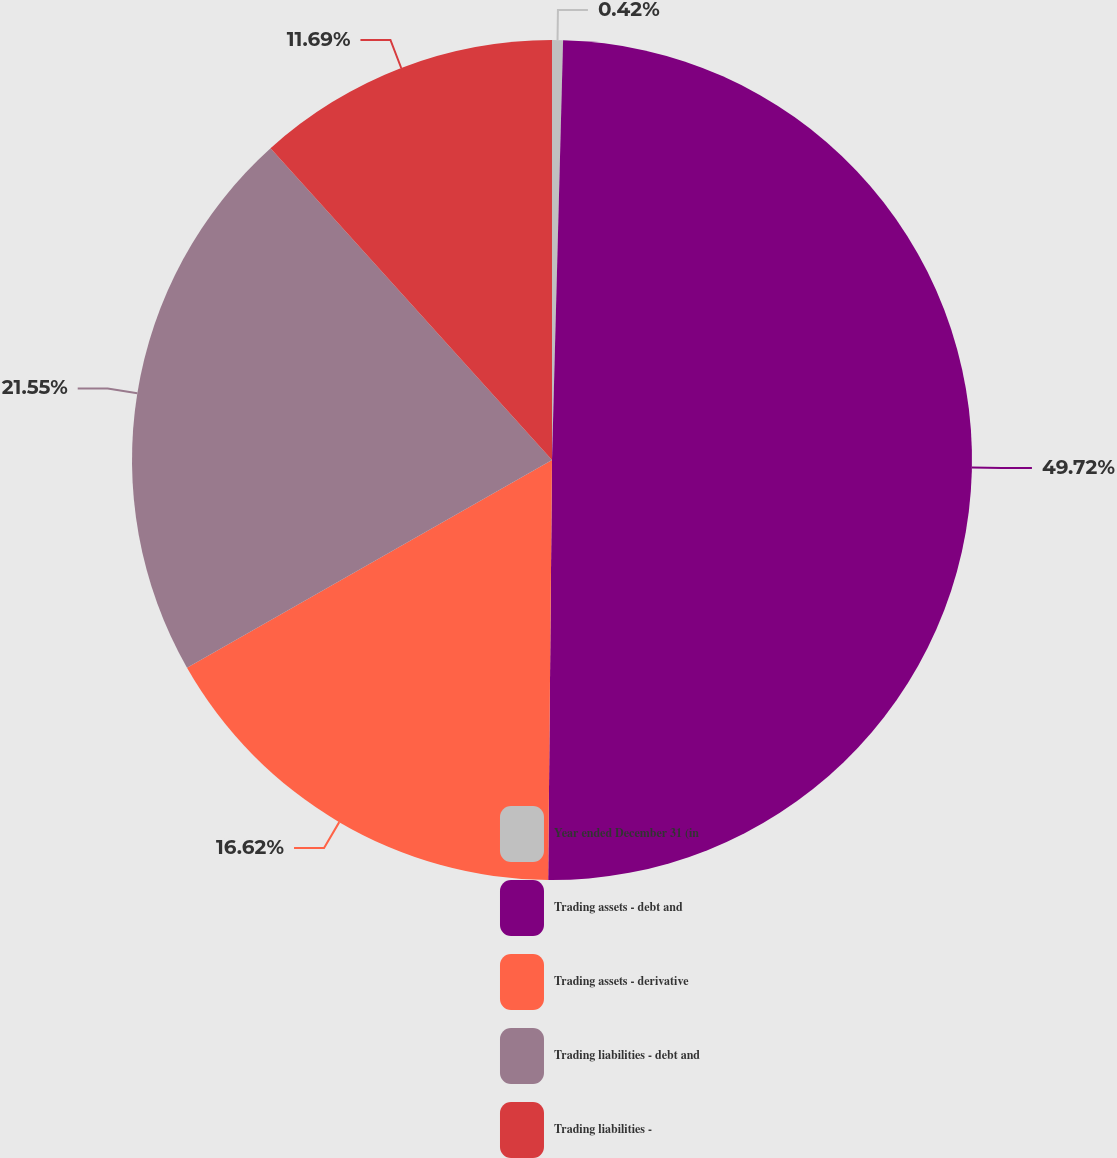<chart> <loc_0><loc_0><loc_500><loc_500><pie_chart><fcel>Year ended December 31 (in<fcel>Trading assets - debt and<fcel>Trading assets - derivative<fcel>Trading liabilities - debt and<fcel>Trading liabilities -<nl><fcel>0.42%<fcel>49.73%<fcel>16.62%<fcel>21.55%<fcel>11.69%<nl></chart> 